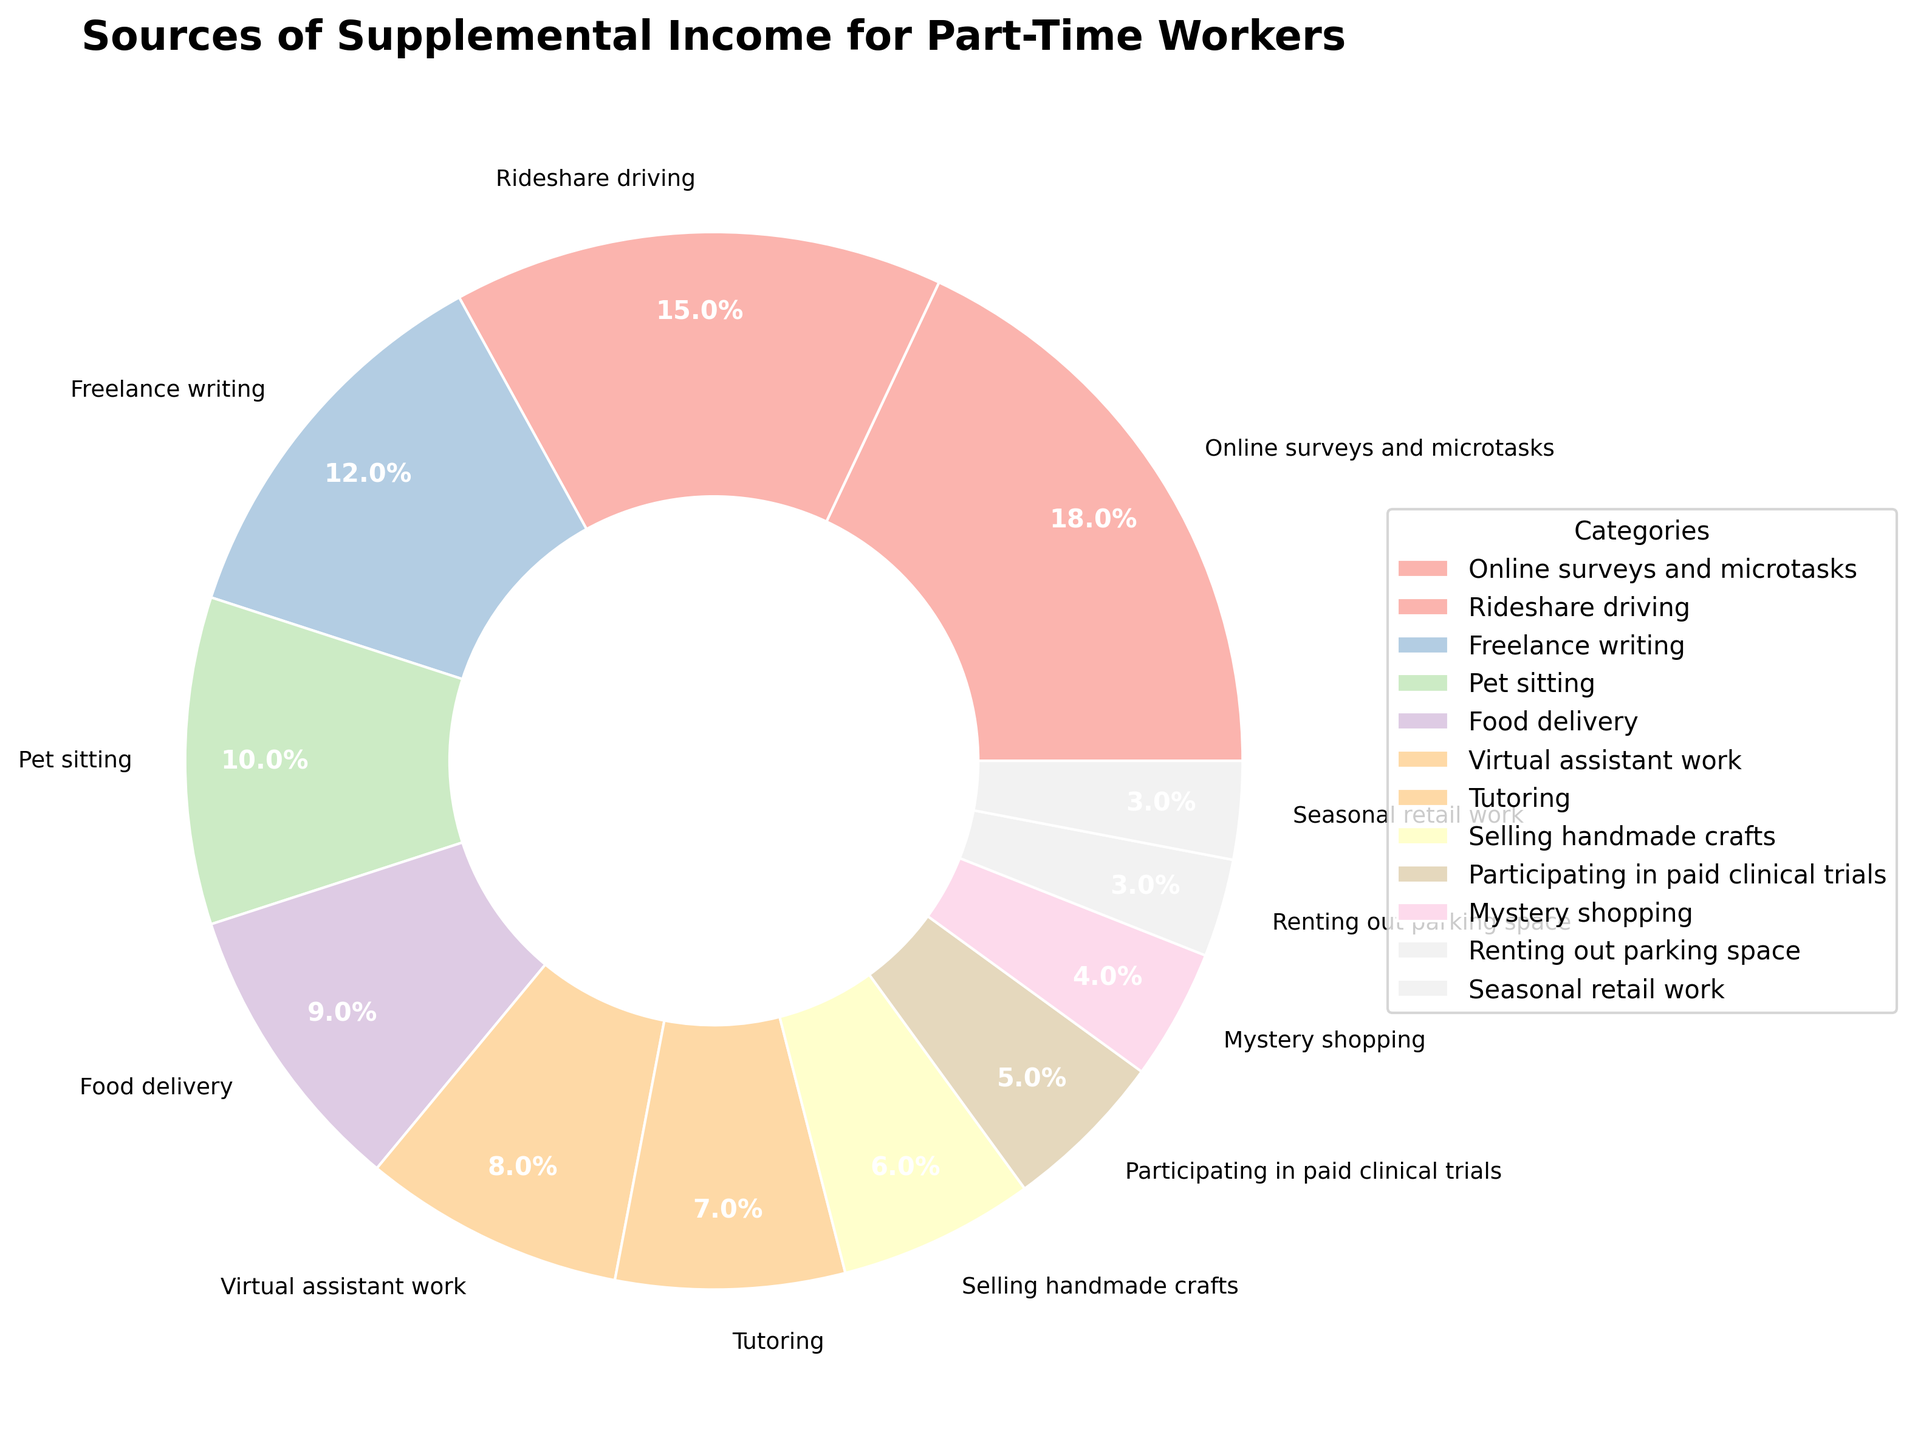Which category accounts for the largest percentage of supplemental income for part-time workers? The pie chart shows that "Online surveys and microtasks" has the largest wedge. The percentage attached to it is 18%.
Answer: Online surveys and microtasks What is the total percentage of income sources related to transportation (including rideshare driving and food delivery)? Add the percentages for "Rideshare driving" and "Food delivery". "Rideshare driving" is 15% and "Food delivery" is 9%. The sum is 15% + 9%.
Answer: 24% How many categories individually contribute 10% or more to the supplemental income sources? Locate all wedges with percentages of 10% or greater. They are "Online surveys and microtasks" (18%), "Rideshare driving" (15%), "Freelance writing" (12%), and "Pet sitting" (10%). Count these categories.
Answer: 4 Are there more categories contributing less than 10% or 10% and above to the supplemental income? Count the categories with less than 10% and those with 10% and above. Less than 10%: 8 categories. 10% and above: 4 categories.
Answer: Less than 10% Which category contributes the least to the supplemental income sources? The pie chart shows that "Renting out parking space" and "Seasonal retail work" both have the smallest wedges with the same percentage of 3%.
Answer: Renting out parking space, Seasonal retail work Compare the contribution of "Virtual assistant work" and "Tutoring". Which one contributes more? Identify the percentages for "Virtual assistant work" (8%) and "Tutoring" (7%). "Virtual assistant work" has a higher percentage.
Answer: Virtual assistant work Sum the combined contributions of "Selling handmade crafts" and "Participating in paid clinical trials". Add the percentages for "Selling handmade crafts" (6%) and "Participating in paid clinical trials" (5%). The sum is 6% + 5%.
Answer: 11% Which category has a slightly higher contribution than "Mystery shopping"? "Mystery shopping" is at 4%. The next smallest wedge is "Participating in paid clinical trials" at 5%.
Answer: Participating in paid clinical trials 